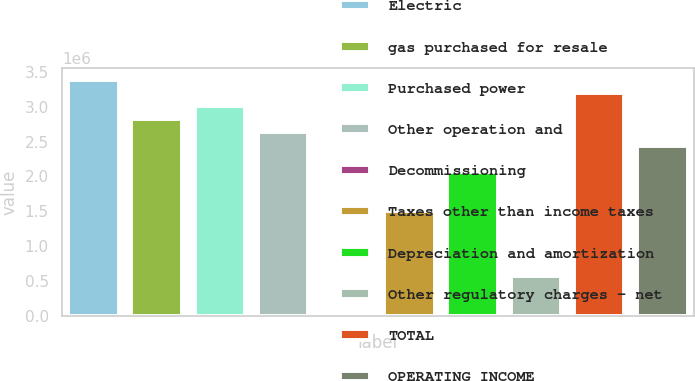Convert chart. <chart><loc_0><loc_0><loc_500><loc_500><bar_chart><fcel>Electric<fcel>gas purchased for resale<fcel>Purchased power<fcel>Other operation and<fcel>Decommissioning<fcel>Taxes other than income taxes<fcel>Depreciation and amortization<fcel>Other regulatory charges - net<fcel>TOTAL<fcel>OPERATING INCOME<nl><fcel>3.38428e+06<fcel>2.82026e+06<fcel>3.00827e+06<fcel>2.63225e+06<fcel>164<fcel>1.50422e+06<fcel>2.06823e+06<fcel>564183<fcel>3.19627e+06<fcel>2.44425e+06<nl></chart> 